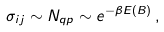Convert formula to latex. <formula><loc_0><loc_0><loc_500><loc_500>\sigma _ { i j } \sim N _ { q p } \sim e ^ { - \beta E ( B ) } \, ,</formula> 